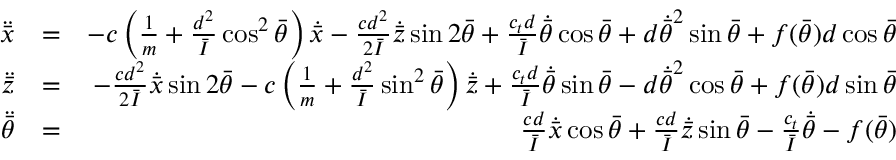Convert formula to latex. <formula><loc_0><loc_0><loc_500><loc_500>\begin{array} { r l r } { \ddot { \bar { x } } } & { = } & { - c \left ( \frac { 1 } { m } + \frac { d ^ { 2 } } { \bar { I } } \cos ^ { 2 } \bar { \theta } \right ) \dot { \bar { x } } - \frac { c d ^ { 2 } } { 2 \bar { I } } \dot { \bar { z } } \sin 2 \bar { \theta } + \frac { c _ { t } d } { \bar { I } } \dot { \bar { \theta } } \cos \bar { \theta } + d \dot { \bar { \theta } } ^ { 2 } \sin \bar { \theta } + f ( \bar { \theta } ) d \cos \bar { \theta } } \\ { \ddot { \bar { z } } } & { = } & { - \frac { c d ^ { 2 } } { 2 \bar { I } } \dot { \bar { x } } \sin 2 \bar { \theta } - c \left ( \frac { 1 } { m } + \frac { d ^ { 2 } } { \bar { I } } \sin ^ { 2 } \bar { \theta } \right ) \dot { \bar { z } } + \frac { c _ { t } d } { \bar { I } } \dot { \bar { \theta } } \sin \bar { \theta } - d \dot { \bar { \theta } } ^ { 2 } \cos \bar { \theta } + f ( \bar { \theta } ) d \sin \bar { \theta } } \\ { \ddot { \bar { \theta } } } & { = } & { \frac { c d } { \bar { I } } \dot { \bar { x } } \cos \bar { \theta } + \frac { c d } { \bar { I } } \dot { \bar { z } } \sin \bar { \theta } - \frac { c _ { t } } { \bar { I } } \dot { \bar { \theta } } - f ( \bar { \theta } ) } \end{array}</formula> 